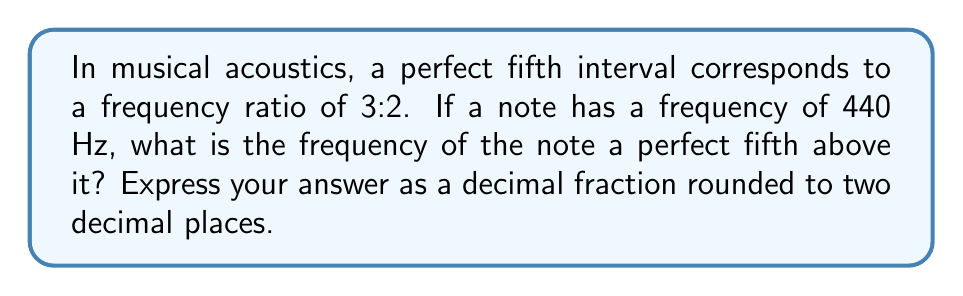Solve this math problem. To solve this problem, we'll follow these steps:

1) First, let's understand what the frequency ratio means. A ratio of 3:2 indicates that for every 2 units of the lower frequency, the higher frequency has 3 units.

2) We can express this mathematically as:

   $$\frac{\text{Higher Frequency}}{\text{Lower Frequency}} = \frac{3}{2}$$

3) We're given that the lower frequency is 440 Hz. Let's call the higher frequency $f$. We can set up the equation:

   $$\frac{f}{440} = \frac{3}{2}$$

4) To solve for $f$, we multiply both sides by 440:

   $$f = 440 \cdot \frac{3}{2}$$

5) Now we can perform the multiplication:

   $$f = \frac{440 \cdot 3}{2} = \frac{1320}{2} = 660$$

6) Therefore, the frequency of the note a perfect fifth above 440 Hz is 660 Hz.

7) The question asks for the answer as a decimal fraction. 660 is already a whole number, so it doesn't need to be expressed as a fraction.

8) Rounding to two decimal places gives us 660.00 Hz.
Answer: 660.00 Hz 